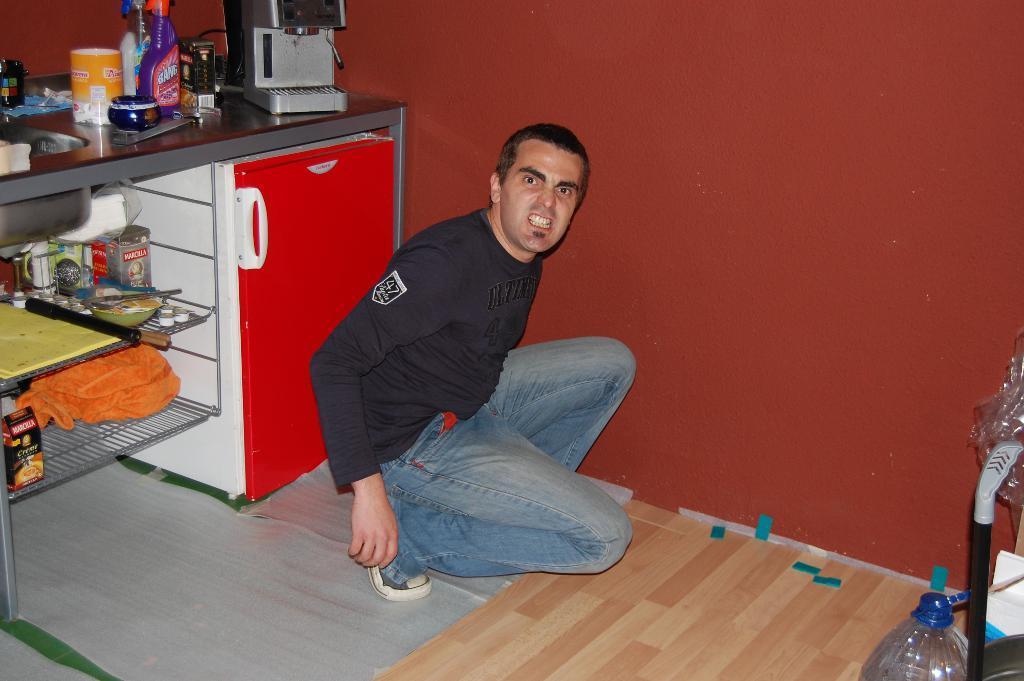Can you describe this image briefly? On the background we can see a wall in red colour. This is a floor. We can see one man with a black colour t shirt on the floor. This is a bottle. Here we can see a desk and a coffee machine on it. Here we can see two racks and few boxes and items on ir. 